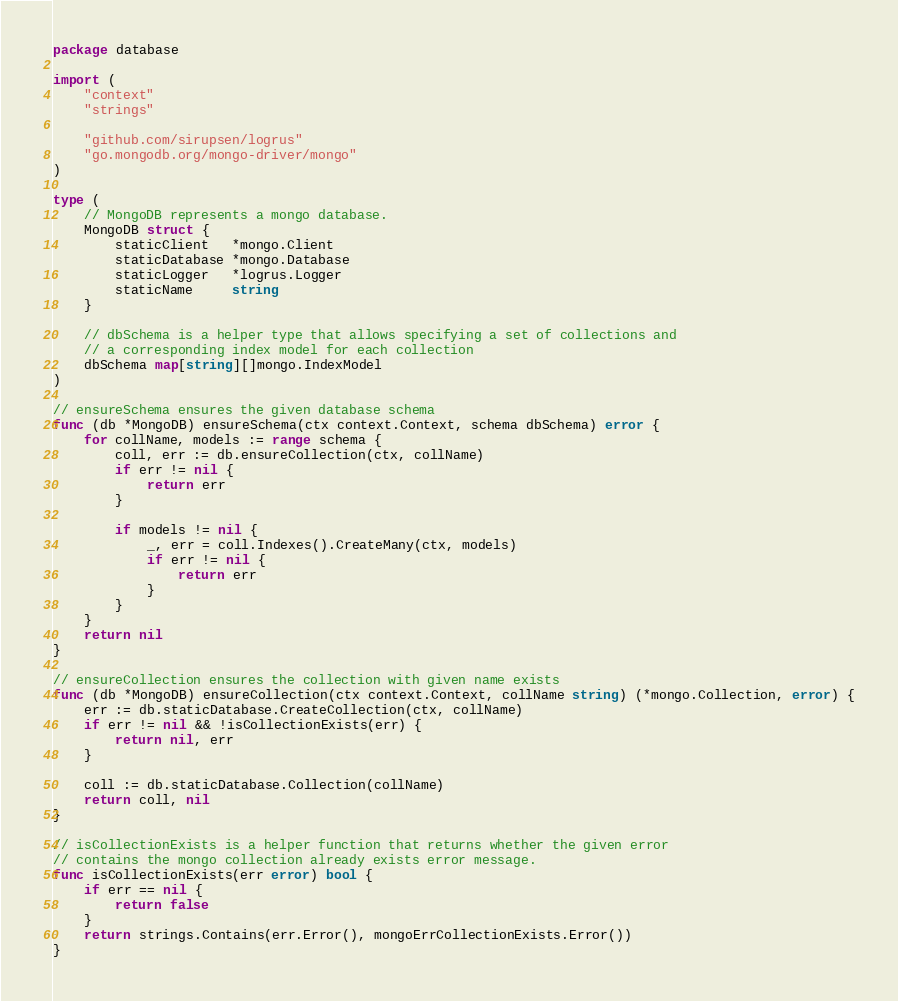Convert code to text. <code><loc_0><loc_0><loc_500><loc_500><_Go_>package database

import (
	"context"
	"strings"

	"github.com/sirupsen/logrus"
	"go.mongodb.org/mongo-driver/mongo"
)

type (
	// MongoDB represents a mongo database.
	MongoDB struct {
		staticClient   *mongo.Client
		staticDatabase *mongo.Database
		staticLogger   *logrus.Logger
		staticName     string
	}

	// dbSchema is a helper type that allows specifying a set of collections and
	// a corresponding index model for each collection
	dbSchema map[string][]mongo.IndexModel
)

// ensureSchema ensures the given database schema
func (db *MongoDB) ensureSchema(ctx context.Context, schema dbSchema) error {
	for collName, models := range schema {
		coll, err := db.ensureCollection(ctx, collName)
		if err != nil {
			return err
		}

		if models != nil {
			_, err = coll.Indexes().CreateMany(ctx, models)
			if err != nil {
				return err
			}
		}
	}
	return nil
}

// ensureCollection ensures the collection with given name exists
func (db *MongoDB) ensureCollection(ctx context.Context, collName string) (*mongo.Collection, error) {
	err := db.staticDatabase.CreateCollection(ctx, collName)
	if err != nil && !isCollectionExists(err) {
		return nil, err
	}

	coll := db.staticDatabase.Collection(collName)
	return coll, nil
}

// isCollectionExists is a helper function that returns whether the given error
// contains the mongo collection already exists error message.
func isCollectionExists(err error) bool {
	if err == nil {
		return false
	}
	return strings.Contains(err.Error(), mongoErrCollectionExists.Error())
}
</code> 